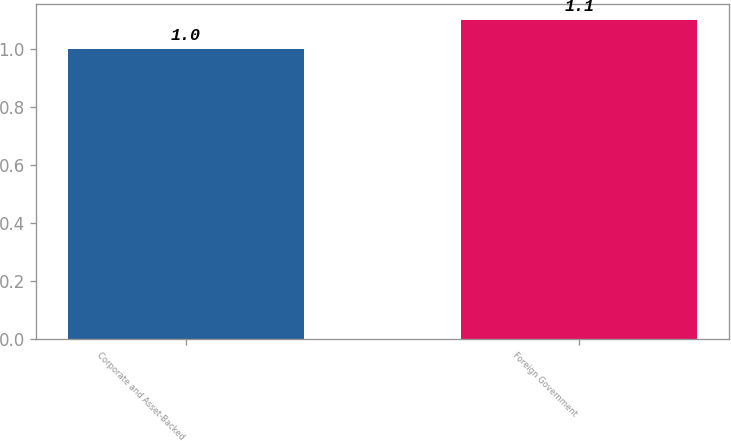Convert chart to OTSL. <chart><loc_0><loc_0><loc_500><loc_500><bar_chart><fcel>Corporate and Asset-Backed<fcel>Foreign Government<nl><fcel>1<fcel>1.1<nl></chart> 